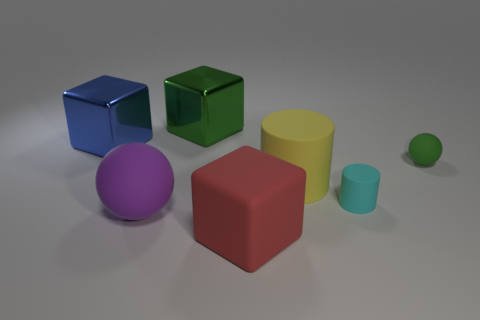What color is the large rubber cylinder?
Ensure brevity in your answer.  Yellow. What size is the metal cube in front of the large green shiny block?
Offer a very short reply. Large. How many tiny rubber cylinders have the same color as the large matte block?
Your answer should be very brief. 0. There is a metallic thing in front of the big green shiny block; is there a tiny matte cylinder in front of it?
Offer a very short reply. Yes. Does the large block that is on the right side of the large green metallic thing have the same color as the matte sphere that is behind the purple thing?
Ensure brevity in your answer.  No. There is a sphere that is the same size as the blue metallic block; what color is it?
Keep it short and to the point. Purple. Are there an equal number of tiny green balls to the left of the green rubber thing and tiny green objects that are in front of the cyan matte thing?
Offer a very short reply. Yes. What is the big block that is to the left of the green object behind the small green rubber thing made of?
Make the answer very short. Metal. How many objects are either blocks or tiny things?
Ensure brevity in your answer.  5. The thing that is the same color as the tiny rubber ball is what size?
Provide a succinct answer. Large. 